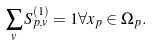<formula> <loc_0><loc_0><loc_500><loc_500>\sum _ { v } S ^ { ( 1 ) } _ { p , v } = 1 \forall x _ { p } \in \Omega _ { p } .</formula> 